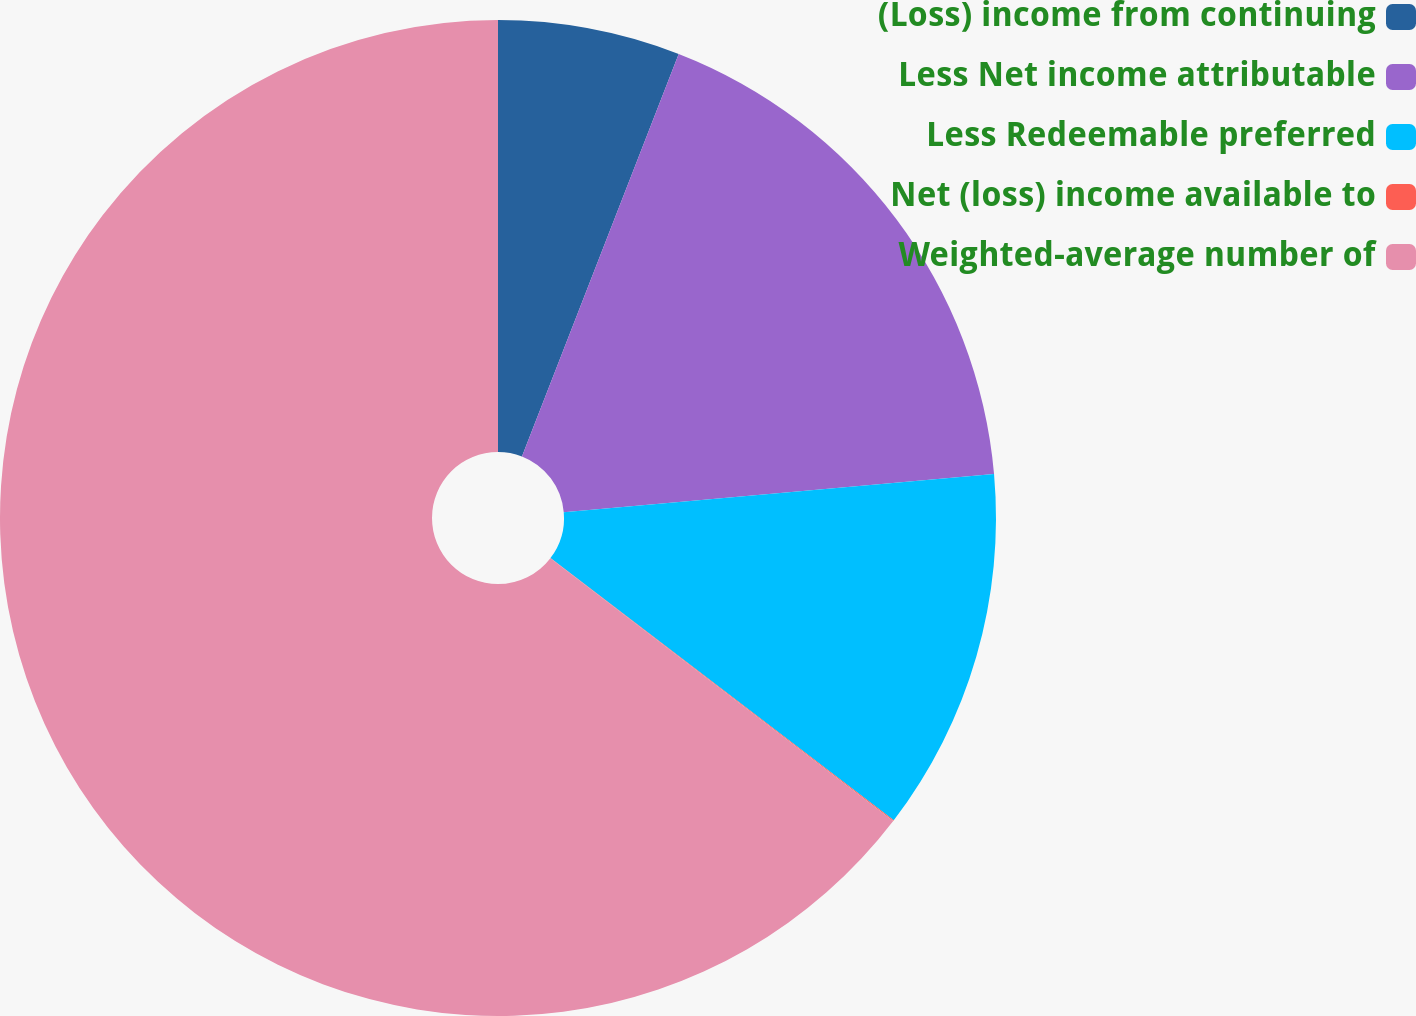<chart> <loc_0><loc_0><loc_500><loc_500><pie_chart><fcel>(Loss) income from continuing<fcel>Less Net income attributable<fcel>Less Redeemable preferred<fcel>Net (loss) income available to<fcel>Weighted-average number of<nl><fcel>5.91%<fcel>17.68%<fcel>11.79%<fcel>0.03%<fcel>64.59%<nl></chart> 